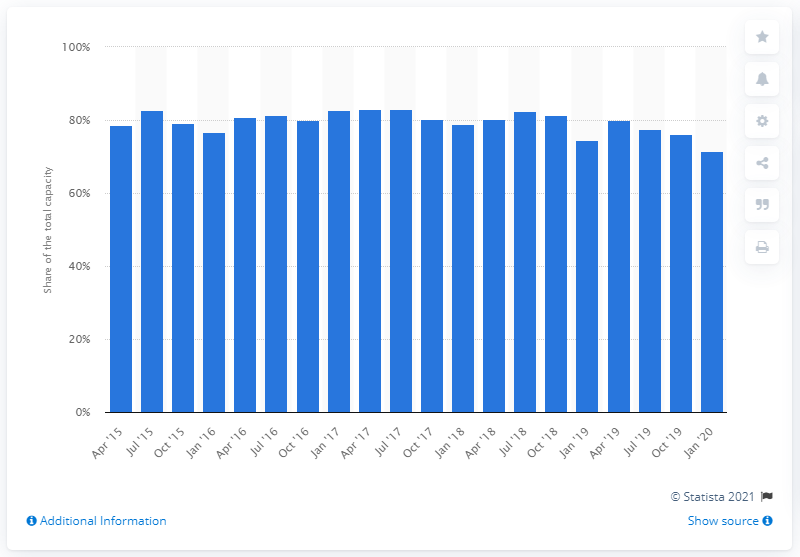Highlight a few significant elements in this photo. The Dutch textile industry used 71.4% of its total capacity in January 2020. 